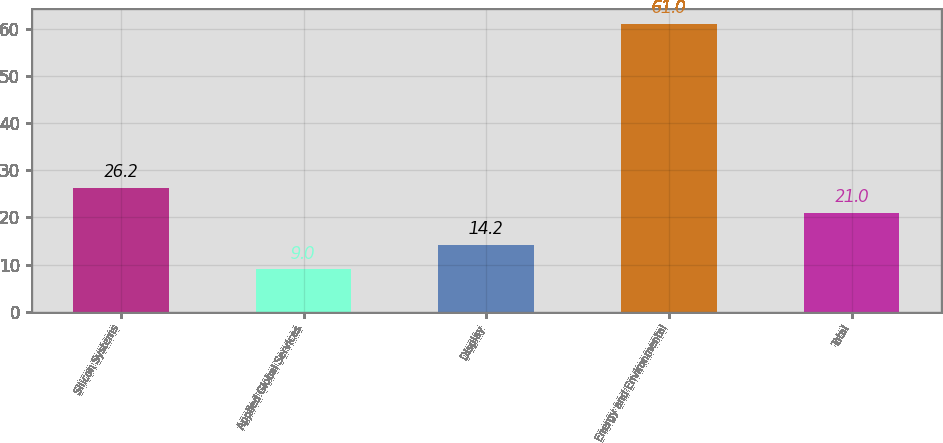Convert chart. <chart><loc_0><loc_0><loc_500><loc_500><bar_chart><fcel>Silicon Systems<fcel>Applied Global Services<fcel>Display<fcel>Energy and Environmental<fcel>Total<nl><fcel>26.2<fcel>9<fcel>14.2<fcel>61<fcel>21<nl></chart> 